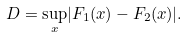Convert formula to latex. <formula><loc_0><loc_0><loc_500><loc_500>D = \underset { x } \sup | F _ { 1 } ( x ) - F _ { 2 } ( x ) | .</formula> 